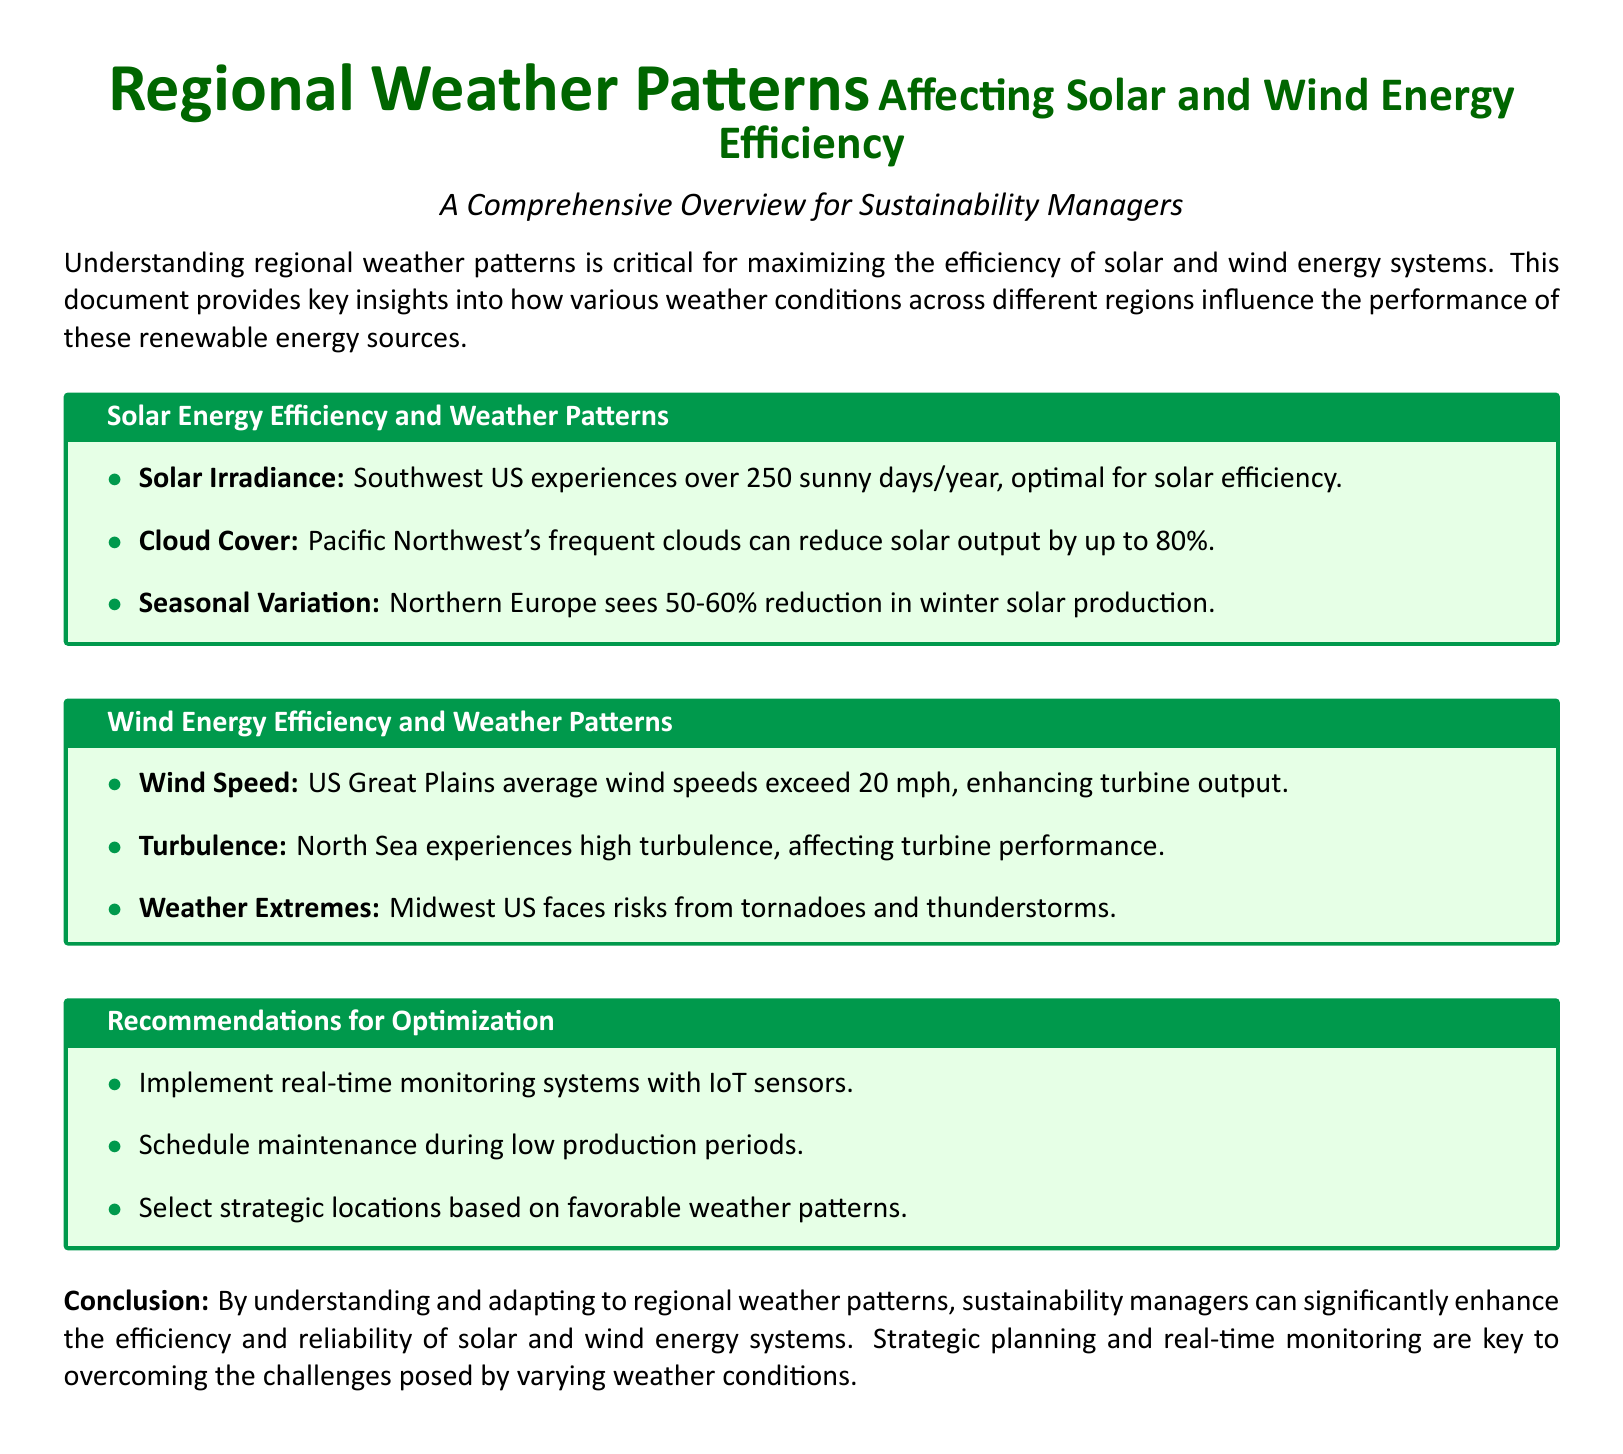What region in the US has over 250 sunny days per year? The Southwest US is noted for experiencing over 250 sunny days each year, which is optimal for solar efficiency.
Answer: Southwest US How much can cloud cover in the Pacific Northwest reduce solar output? The document states that frequent clouds in the Pacific Northwest can reduce solar output by up to 80%.
Answer: 80% What is the average wind speed in the US Great Plains? The average wind speeds in the US Great Plains are mentioned to exceed 20 mph, which enhances turbine output.
Answer: 20 mph Which region faces risks from tornadoes? The document indicates that the Midwest US faces risks from tornadoes and thunderstorms.
Answer: Midwest US What is a recommended implementation for optimizing renewable energy systems? The recommendations section suggests implementing real-time monitoring systems with IoT sensors for optimization.
Answer: Real-time monitoring systems How does seasonal variation affect solar production in Northern Europe? It notes that Northern Europe sees a 50-60% reduction in solar production during winter.
Answer: 50-60% What type of issues does high turbulence affect in wind energy? The document mentions that high turbulence in the North Sea affects turbine performance.
Answer: Turbine performance Which strategy is recommended for maintenance scheduling? The document advises scheduling maintenance during low production periods for optimization purposes.
Answer: Low production periods 